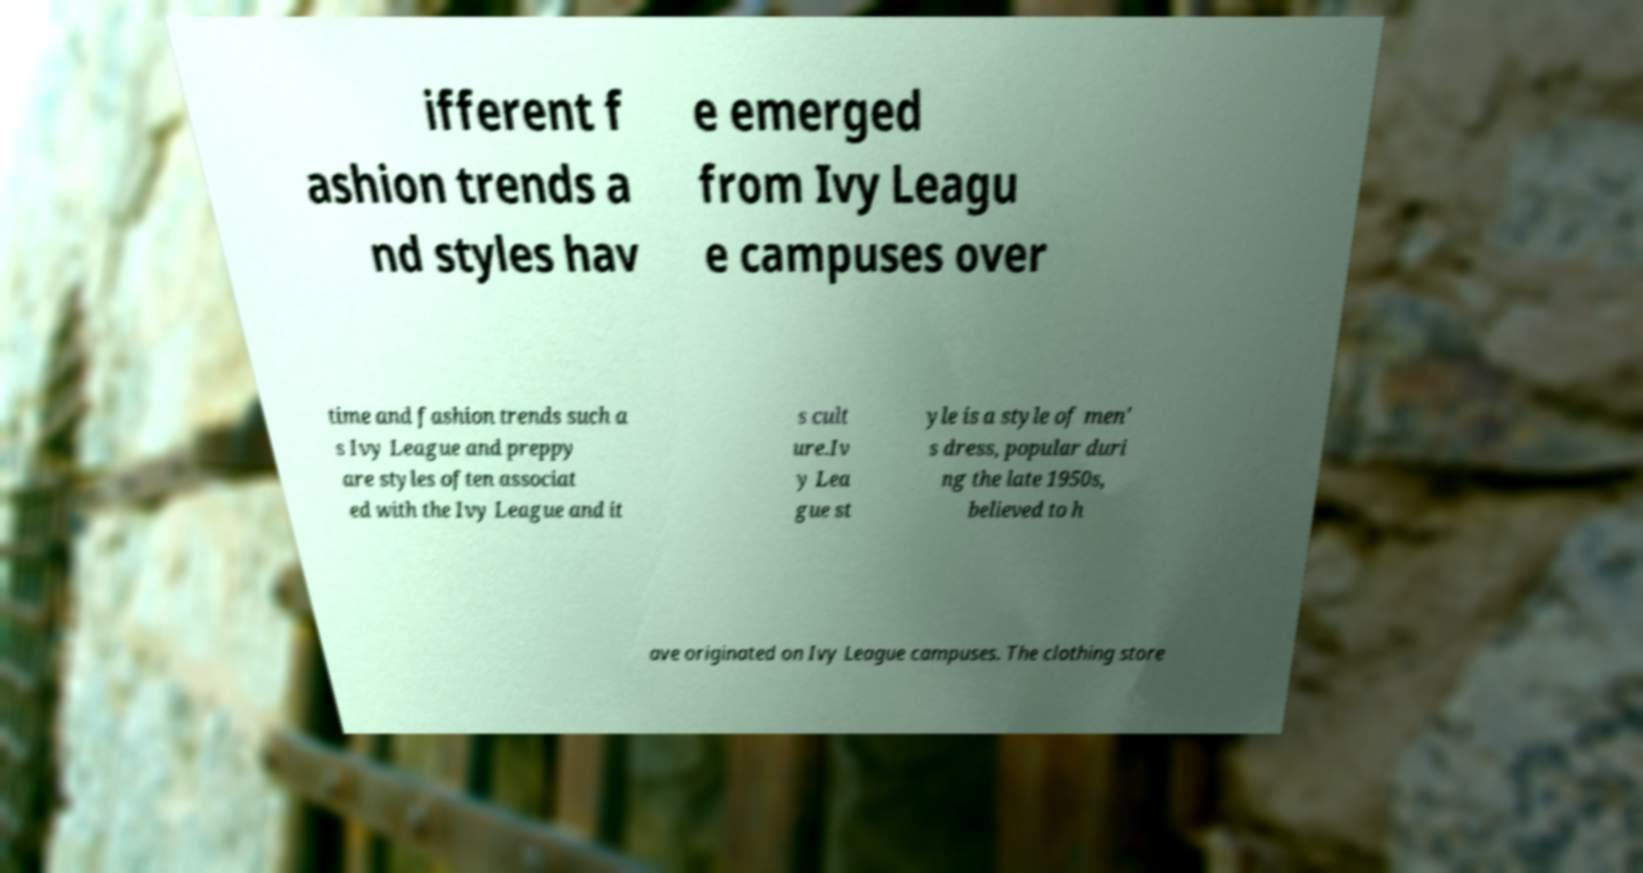Could you extract and type out the text from this image? ifferent f ashion trends a nd styles hav e emerged from Ivy Leagu e campuses over time and fashion trends such a s Ivy League and preppy are styles often associat ed with the Ivy League and it s cult ure.Iv y Lea gue st yle is a style of men' s dress, popular duri ng the late 1950s, believed to h ave originated on Ivy League campuses. The clothing store 